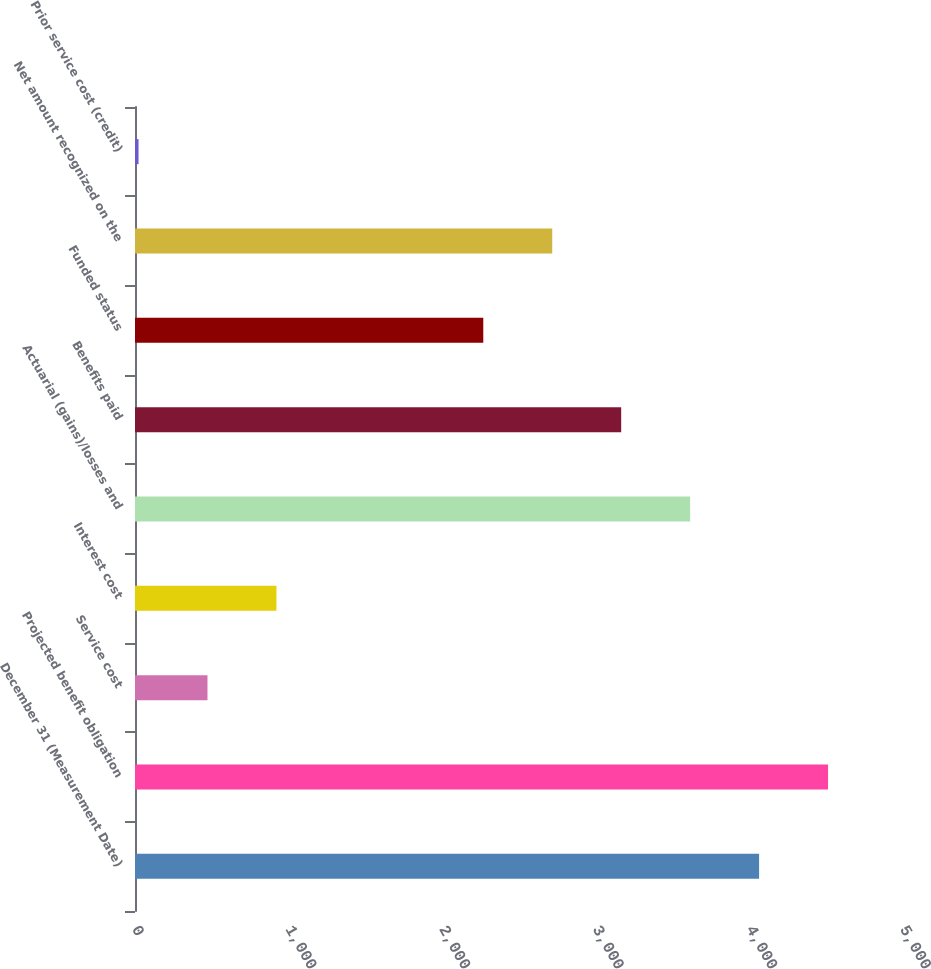Convert chart. <chart><loc_0><loc_0><loc_500><loc_500><bar_chart><fcel>December 31 (Measurement Date)<fcel>Projected benefit obligation<fcel>Service cost<fcel>Interest cost<fcel>Actuarial (gains)/losses and<fcel>Benefits paid<fcel>Funded status<fcel>Net amount recognized on the<fcel>Prior service cost (credit)<nl><fcel>4063.1<fcel>4512<fcel>471.9<fcel>920.8<fcel>3614.2<fcel>3165.3<fcel>2267.5<fcel>2716.4<fcel>23<nl></chart> 